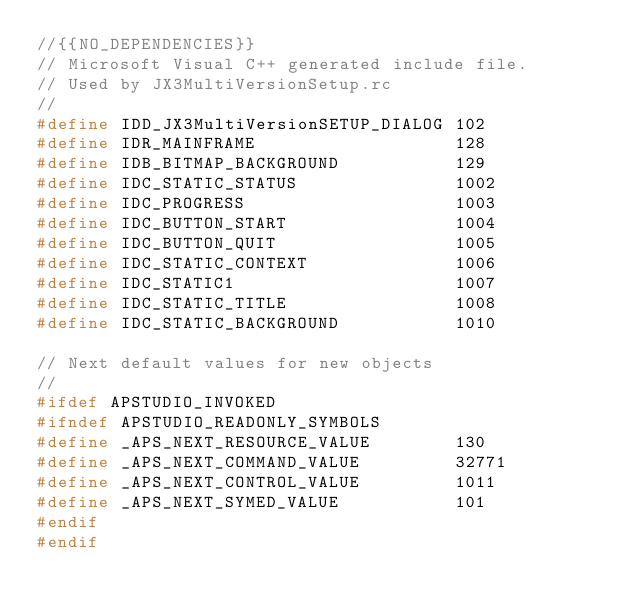<code> <loc_0><loc_0><loc_500><loc_500><_C_>//{{NO_DEPENDENCIES}}
// Microsoft Visual C++ generated include file.
// Used by JX3MultiVersionSetup.rc
//
#define IDD_JX3MultiVersionSETUP_DIALOG 102
#define IDR_MAINFRAME                   128
#define IDB_BITMAP_BACKGROUND           129
#define IDC_STATIC_STATUS               1002
#define IDC_PROGRESS                    1003
#define IDC_BUTTON_START                1004
#define IDC_BUTTON_QUIT                 1005
#define IDC_STATIC_CONTEXT              1006
#define IDC_STATIC1                     1007
#define IDC_STATIC_TITLE                1008
#define IDC_STATIC_BACKGROUND           1010

// Next default values for new objects
// 
#ifdef APSTUDIO_INVOKED
#ifndef APSTUDIO_READONLY_SYMBOLS
#define _APS_NEXT_RESOURCE_VALUE        130
#define _APS_NEXT_COMMAND_VALUE         32771
#define _APS_NEXT_CONTROL_VALUE         1011
#define _APS_NEXT_SYMED_VALUE           101
#endif
#endif
</code> 